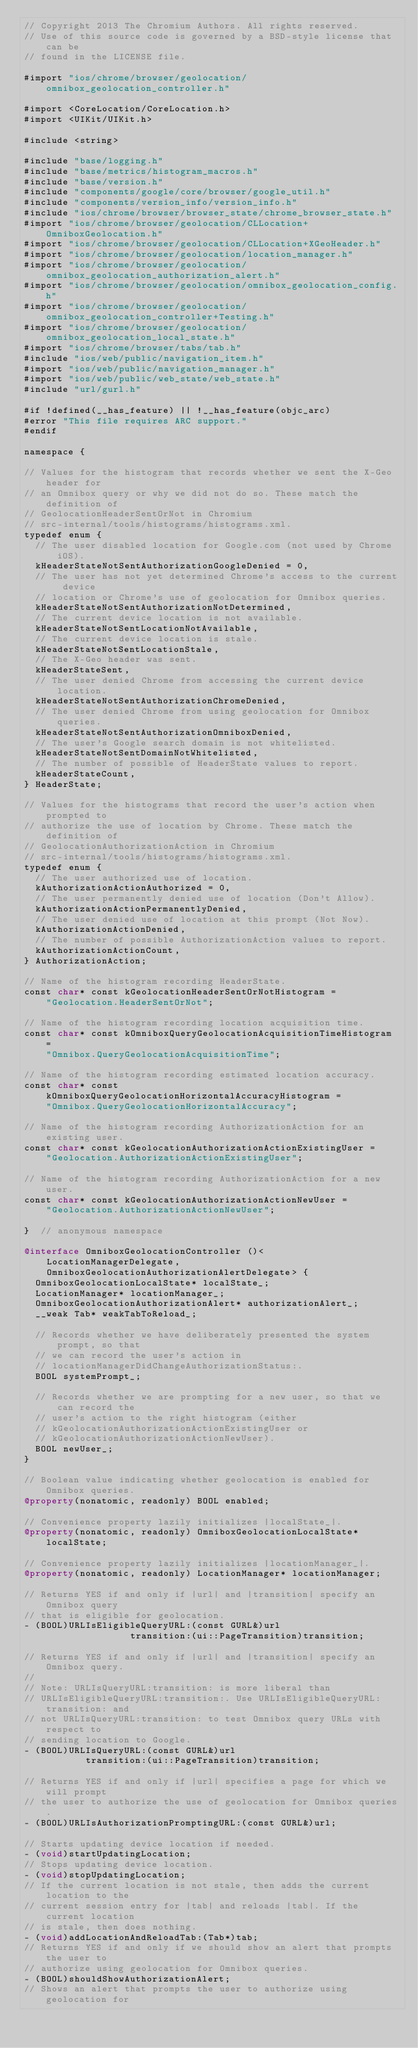<code> <loc_0><loc_0><loc_500><loc_500><_ObjectiveC_>// Copyright 2013 The Chromium Authors. All rights reserved.
// Use of this source code is governed by a BSD-style license that can be
// found in the LICENSE file.

#import "ios/chrome/browser/geolocation/omnibox_geolocation_controller.h"

#import <CoreLocation/CoreLocation.h>
#import <UIKit/UIKit.h>

#include <string>

#include "base/logging.h"
#include "base/metrics/histogram_macros.h"
#include "base/version.h"
#include "components/google/core/browser/google_util.h"
#include "components/version_info/version_info.h"
#include "ios/chrome/browser/browser_state/chrome_browser_state.h"
#import "ios/chrome/browser/geolocation/CLLocation+OmniboxGeolocation.h"
#import "ios/chrome/browser/geolocation/CLLocation+XGeoHeader.h"
#import "ios/chrome/browser/geolocation/location_manager.h"
#import "ios/chrome/browser/geolocation/omnibox_geolocation_authorization_alert.h"
#import "ios/chrome/browser/geolocation/omnibox_geolocation_config.h"
#import "ios/chrome/browser/geolocation/omnibox_geolocation_controller+Testing.h"
#import "ios/chrome/browser/geolocation/omnibox_geolocation_local_state.h"
#import "ios/chrome/browser/tabs/tab.h"
#include "ios/web/public/navigation_item.h"
#import "ios/web/public/navigation_manager.h"
#import "ios/web/public/web_state/web_state.h"
#include "url/gurl.h"

#if !defined(__has_feature) || !__has_feature(objc_arc)
#error "This file requires ARC support."
#endif

namespace {

// Values for the histogram that records whether we sent the X-Geo header for
// an Omnibox query or why we did not do so. These match the definition of
// GeolocationHeaderSentOrNot in Chromium
// src-internal/tools/histograms/histograms.xml.
typedef enum {
  // The user disabled location for Google.com (not used by Chrome iOS).
  kHeaderStateNotSentAuthorizationGoogleDenied = 0,
  // The user has not yet determined Chrome's access to the current device
  // location or Chrome's use of geolocation for Omnibox queries.
  kHeaderStateNotSentAuthorizationNotDetermined,
  // The current device location is not available.
  kHeaderStateNotSentLocationNotAvailable,
  // The current device location is stale.
  kHeaderStateNotSentLocationStale,
  // The X-Geo header was sent.
  kHeaderStateSent,
  // The user denied Chrome from accessing the current device location.
  kHeaderStateNotSentAuthorizationChromeDenied,
  // The user denied Chrome from using geolocation for Omnibox queries.
  kHeaderStateNotSentAuthorizationOmniboxDenied,
  // The user's Google search domain is not whitelisted.
  kHeaderStateNotSentDomainNotWhitelisted,
  // The number of possible of HeaderState values to report.
  kHeaderStateCount,
} HeaderState;

// Values for the histograms that record the user's action when prompted to
// authorize the use of location by Chrome. These match the definition of
// GeolocationAuthorizationAction in Chromium
// src-internal/tools/histograms/histograms.xml.
typedef enum {
  // The user authorized use of location.
  kAuthorizationActionAuthorized = 0,
  // The user permanently denied use of location (Don't Allow).
  kAuthorizationActionPermanentlyDenied,
  // The user denied use of location at this prompt (Not Now).
  kAuthorizationActionDenied,
  // The number of possible AuthorizationAction values to report.
  kAuthorizationActionCount,
} AuthorizationAction;

// Name of the histogram recording HeaderState.
const char* const kGeolocationHeaderSentOrNotHistogram =
    "Geolocation.HeaderSentOrNot";

// Name of the histogram recording location acquisition time.
const char* const kOmniboxQueryGeolocationAcquisitionTimeHistogram =
    "Omnibox.QueryGeolocationAcquisitionTime";

// Name of the histogram recording estimated location accuracy.
const char* const kOmniboxQueryGeolocationHorizontalAccuracyHistogram =
    "Omnibox.QueryGeolocationHorizontalAccuracy";

// Name of the histogram recording AuthorizationAction for an existing user.
const char* const kGeolocationAuthorizationActionExistingUser =
    "Geolocation.AuthorizationActionExistingUser";

// Name of the histogram recording AuthorizationAction for a new user.
const char* const kGeolocationAuthorizationActionNewUser =
    "Geolocation.AuthorizationActionNewUser";

}  // anonymous namespace

@interface OmniboxGeolocationController ()<
    LocationManagerDelegate,
    OmniboxGeolocationAuthorizationAlertDelegate> {
  OmniboxGeolocationLocalState* localState_;
  LocationManager* locationManager_;
  OmniboxGeolocationAuthorizationAlert* authorizationAlert_;
  __weak Tab* weakTabToReload_;

  // Records whether we have deliberately presented the system prompt, so that
  // we can record the user's action in
  // locationManagerDidChangeAuthorizationStatus:.
  BOOL systemPrompt_;

  // Records whether we are prompting for a new user, so that we can record the
  // user's action to the right histogram (either
  // kGeolocationAuthorizationActionExistingUser or
  // kGeolocationAuthorizationActionNewUser).
  BOOL newUser_;
}

// Boolean value indicating whether geolocation is enabled for Omnibox queries.
@property(nonatomic, readonly) BOOL enabled;

// Convenience property lazily initializes |localState_|.
@property(nonatomic, readonly) OmniboxGeolocationLocalState* localState;

// Convenience property lazily initializes |locationManager_|.
@property(nonatomic, readonly) LocationManager* locationManager;

// Returns YES if and only if |url| and |transition| specify an Omnibox query
// that is eligible for geolocation.
- (BOOL)URLIsEligibleQueryURL:(const GURL&)url
                   transition:(ui::PageTransition)transition;

// Returns YES if and only if |url| and |transition| specify an Omnibox query.
//
// Note: URLIsQueryURL:transition: is more liberal than
// URLIsEligibleQueryURL:transition:. Use URLIsEligibleQueryURL:transition: and
// not URLIsQueryURL:transition: to test Omnibox query URLs with respect to
// sending location to Google.
- (BOOL)URLIsQueryURL:(const GURL&)url
           transition:(ui::PageTransition)transition;

// Returns YES if and only if |url| specifies a page for which we will prompt
// the user to authorize the use of geolocation for Omnibox queries.
- (BOOL)URLIsAuthorizationPromptingURL:(const GURL&)url;

// Starts updating device location if needed.
- (void)startUpdatingLocation;
// Stops updating device location.
- (void)stopUpdatingLocation;
// If the current location is not stale, then adds the current location to the
// current session entry for |tab| and reloads |tab|. If the current location
// is stale, then does nothing.
- (void)addLocationAndReloadTab:(Tab*)tab;
// Returns YES if and only if we should show an alert that prompts the user to
// authorize using geolocation for Omnibox queries.
- (BOOL)shouldShowAuthorizationAlert;
// Shows an alert that prompts the user to authorize using geolocation for</code> 